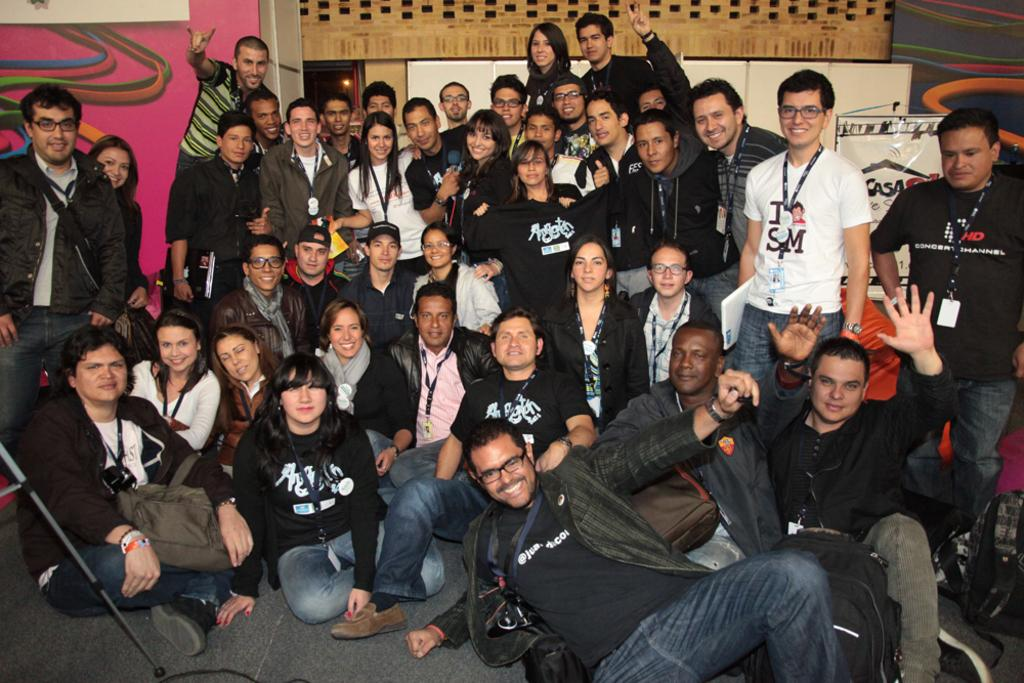How many people are in the image? There is a group of people in the image. What are the people in the image doing? The people are posing for a photo. What can be seen in the background of the image? There are art posters visible in the background of the image. Is there a fire visible in the image? No, there is no fire present in the image. What type of poison can be seen on the art posters in the image? There is no poison mentioned or visible on the art posters in the image. 